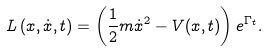Convert formula to latex. <formula><loc_0><loc_0><loc_500><loc_500>L \left ( x , \dot { x } , t \right ) = \left ( \frac { 1 } { 2 } { m \dot { x } ^ { 2 } } - V ( x , t ) \right ) e ^ { \Gamma _ { t } } .</formula> 